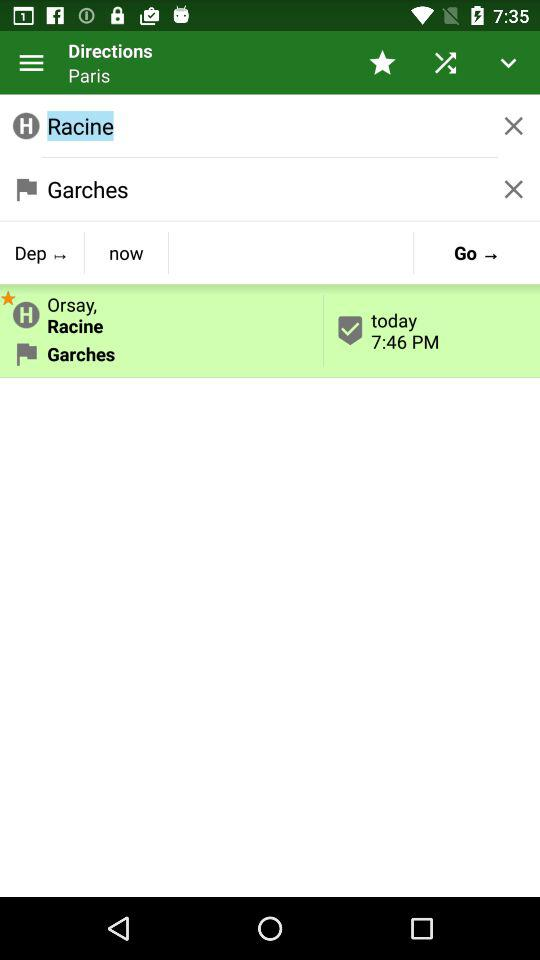What is the selected time for today? The selected time for today is 7:46 PM. 